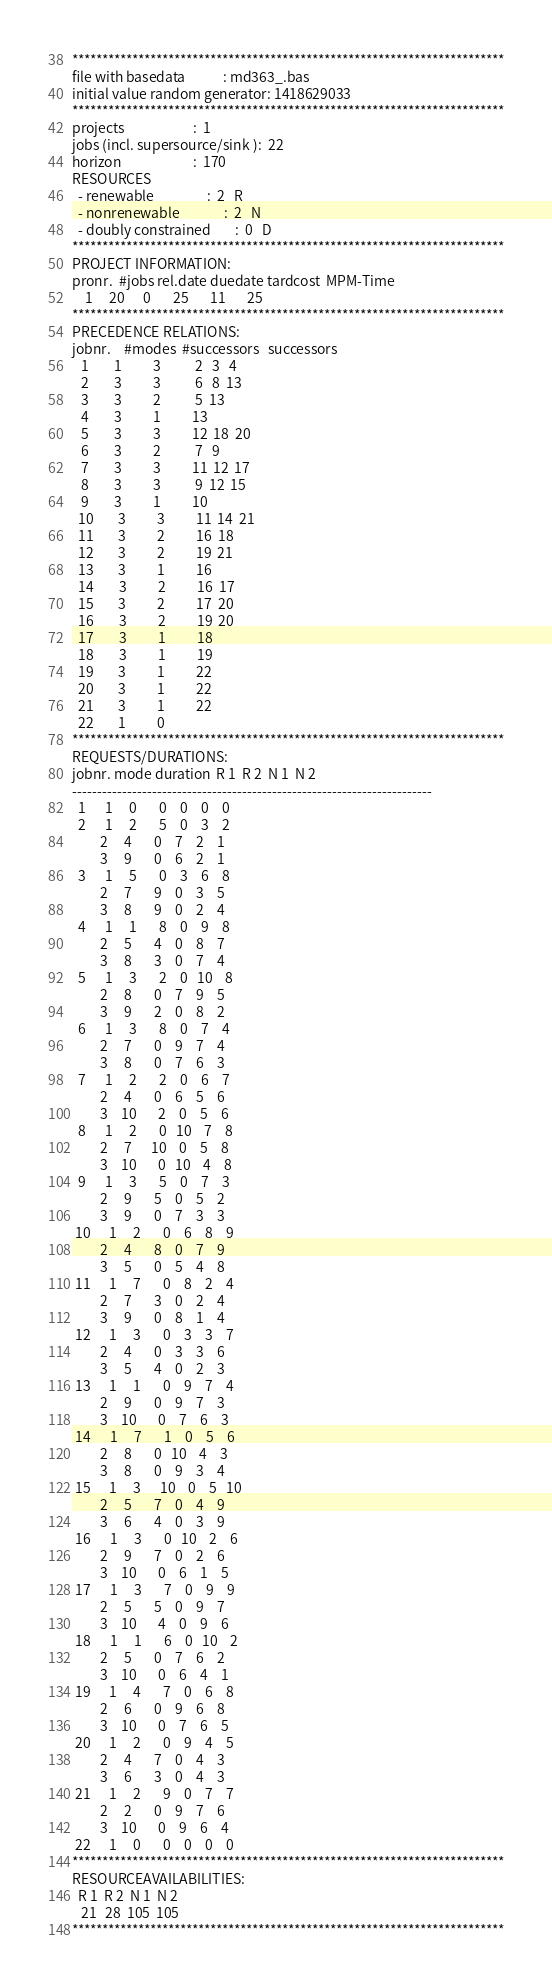<code> <loc_0><loc_0><loc_500><loc_500><_ObjectiveC_>************************************************************************
file with basedata            : md363_.bas
initial value random generator: 1418629033
************************************************************************
projects                      :  1
jobs (incl. supersource/sink ):  22
horizon                       :  170
RESOURCES
  - renewable                 :  2   R
  - nonrenewable              :  2   N
  - doubly constrained        :  0   D
************************************************************************
PROJECT INFORMATION:
pronr.  #jobs rel.date duedate tardcost  MPM-Time
    1     20      0       25       11       25
************************************************************************
PRECEDENCE RELATIONS:
jobnr.    #modes  #successors   successors
   1        1          3           2   3   4
   2        3          3           6   8  13
   3        3          2           5  13
   4        3          1          13
   5        3          3          12  18  20
   6        3          2           7   9
   7        3          3          11  12  17
   8        3          3           9  12  15
   9        3          1          10
  10        3          3          11  14  21
  11        3          2          16  18
  12        3          2          19  21
  13        3          1          16
  14        3          2          16  17
  15        3          2          17  20
  16        3          2          19  20
  17        3          1          18
  18        3          1          19
  19        3          1          22
  20        3          1          22
  21        3          1          22
  22        1          0        
************************************************************************
REQUESTS/DURATIONS:
jobnr. mode duration  R 1  R 2  N 1  N 2
------------------------------------------------------------------------
  1      1     0       0    0    0    0
  2      1     2       5    0    3    2
         2     4       0    7    2    1
         3     9       0    6    2    1
  3      1     5       0    3    6    8
         2     7       9    0    3    5
         3     8       9    0    2    4
  4      1     1       8    0    9    8
         2     5       4    0    8    7
         3     8       3    0    7    4
  5      1     3       2    0   10    8
         2     8       0    7    9    5
         3     9       2    0    8    2
  6      1     3       8    0    7    4
         2     7       0    9    7    4
         3     8       0    7    6    3
  7      1     2       2    0    6    7
         2     4       0    6    5    6
         3    10       2    0    5    6
  8      1     2       0   10    7    8
         2     7      10    0    5    8
         3    10       0   10    4    8
  9      1     3       5    0    7    3
         2     9       5    0    5    2
         3     9       0    7    3    3
 10      1     2       0    6    8    9
         2     4       8    0    7    9
         3     5       0    5    4    8
 11      1     7       0    8    2    4
         2     7       3    0    2    4
         3     9       0    8    1    4
 12      1     3       0    3    3    7
         2     4       0    3    3    6
         3     5       4    0    2    3
 13      1     1       0    9    7    4
         2     9       0    9    7    3
         3    10       0    7    6    3
 14      1     7       1    0    5    6
         2     8       0   10    4    3
         3     8       0    9    3    4
 15      1     3      10    0    5   10
         2     5       7    0    4    9
         3     6       4    0    3    9
 16      1     3       0   10    2    6
         2     9       7    0    2    6
         3    10       0    6    1    5
 17      1     3       7    0    9    9
         2     5       5    0    9    7
         3    10       4    0    9    6
 18      1     1       6    0   10    2
         2     5       0    7    6    2
         3    10       0    6    4    1
 19      1     4       7    0    6    8
         2     6       0    9    6    8
         3    10       0    7    6    5
 20      1     2       0    9    4    5
         2     4       7    0    4    3
         3     6       3    0    4    3
 21      1     2       9    0    7    7
         2     2       0    9    7    6
         3    10       0    9    6    4
 22      1     0       0    0    0    0
************************************************************************
RESOURCEAVAILABILITIES:
  R 1  R 2  N 1  N 2
   21   28  105  105
************************************************************************
</code> 